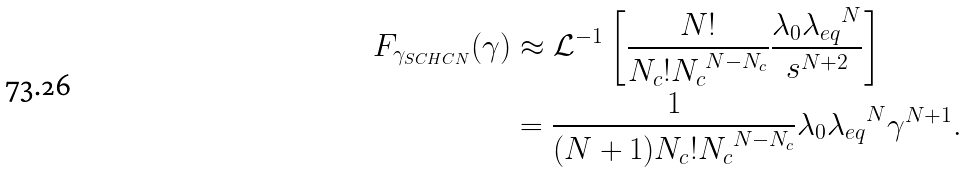Convert formula to latex. <formula><loc_0><loc_0><loc_500><loc_500>F _ { \gamma _ { S C H C N } } ( \gamma ) & \approx \mathcal { L } ^ { - 1 } \left [ \frac { N ! } { N _ { c } ! { N _ { c } } ^ { N - N _ { c } } } \frac { \lambda _ { 0 } { \lambda _ { e q } } ^ { N } } { s ^ { N + 2 } } \right ] \\ & = \frac { 1 } { ( N + 1 ) N _ { c } ! { N _ { c } } ^ { N - N _ { c } } } \lambda _ { 0 } { \lambda _ { e q } } ^ { N } \gamma ^ { N + 1 } .</formula> 